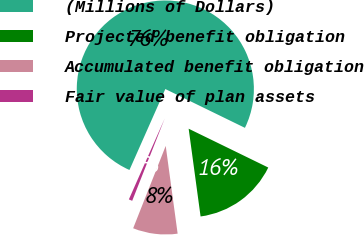Convert chart. <chart><loc_0><loc_0><loc_500><loc_500><pie_chart><fcel>(Millions of Dollars)<fcel>Projected benefit obligation<fcel>Accumulated benefit obligation<fcel>Fair value of plan assets<nl><fcel>75.58%<fcel>15.63%<fcel>8.14%<fcel>0.65%<nl></chart> 